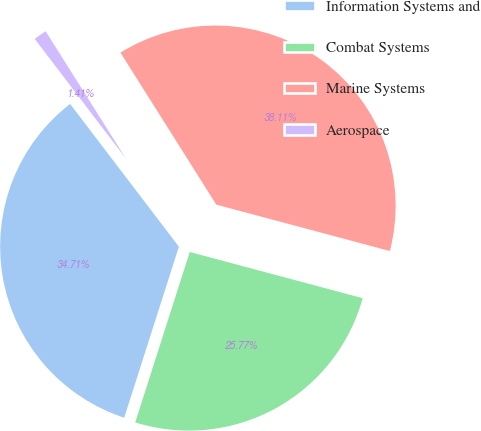<chart> <loc_0><loc_0><loc_500><loc_500><pie_chart><fcel>Information Systems and<fcel>Combat Systems<fcel>Marine Systems<fcel>Aerospace<nl><fcel>34.71%<fcel>25.77%<fcel>38.11%<fcel>1.41%<nl></chart> 